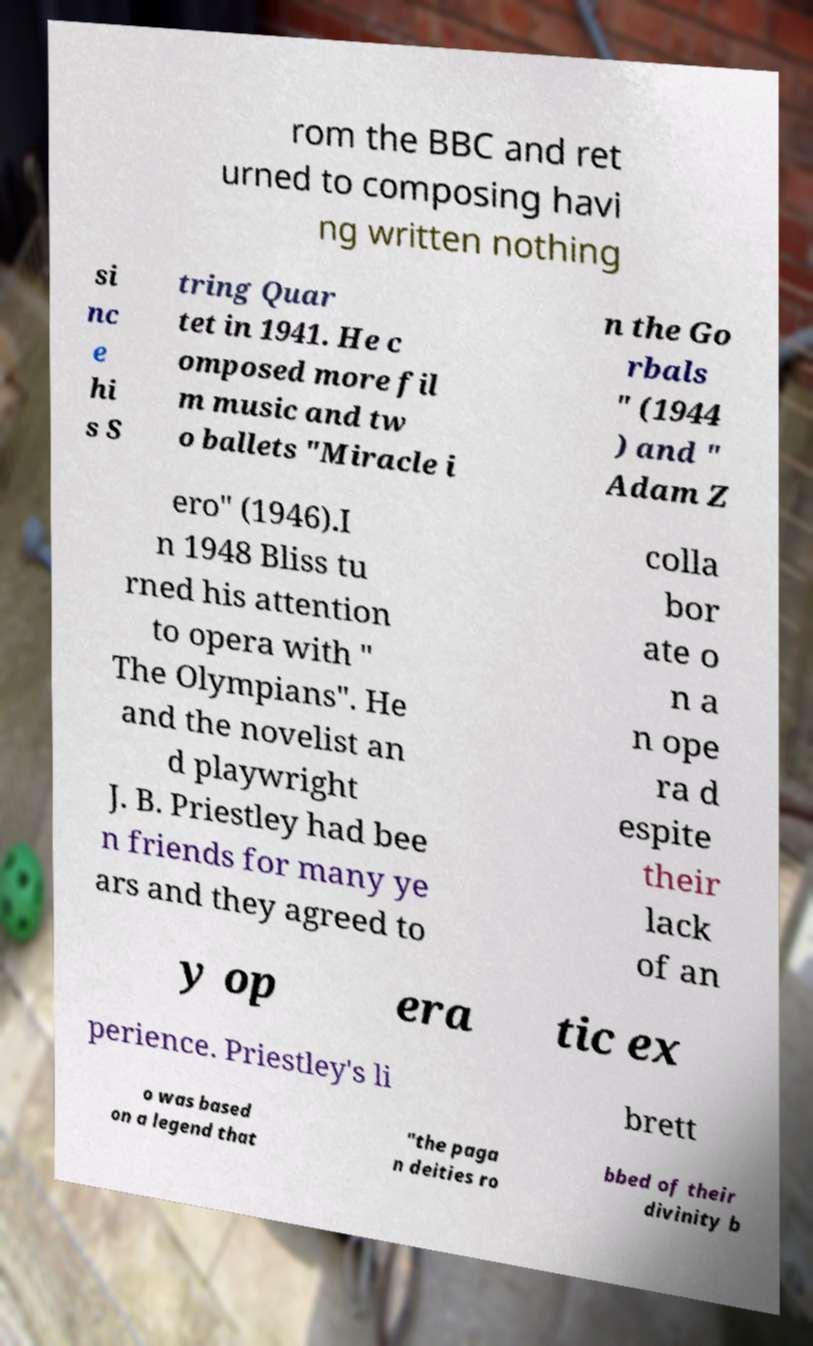Can you accurately transcribe the text from the provided image for me? rom the BBC and ret urned to composing havi ng written nothing si nc e hi s S tring Quar tet in 1941. He c omposed more fil m music and tw o ballets "Miracle i n the Go rbals " (1944 ) and " Adam Z ero" (1946).I n 1948 Bliss tu rned his attention to opera with " The Olympians". He and the novelist an d playwright J. B. Priestley had bee n friends for many ye ars and they agreed to colla bor ate o n a n ope ra d espite their lack of an y op era tic ex perience. Priestley's li brett o was based on a legend that "the paga n deities ro bbed of their divinity b 